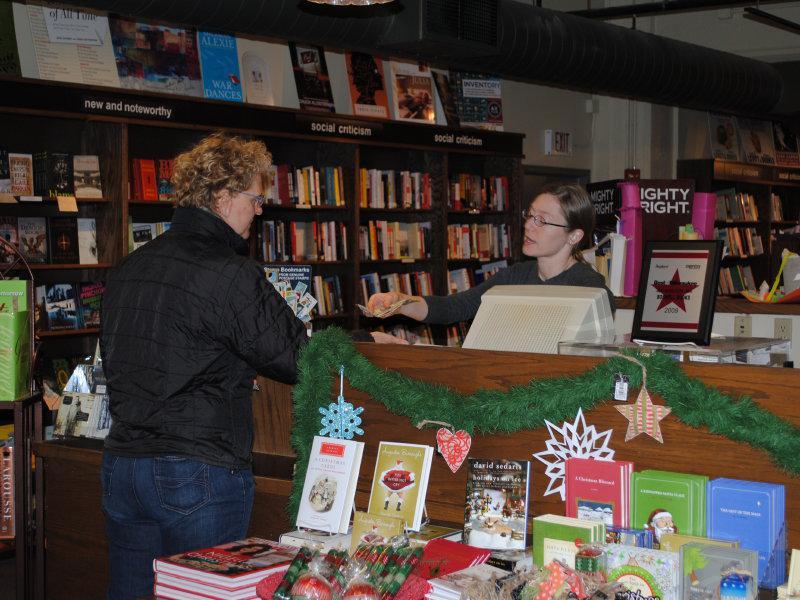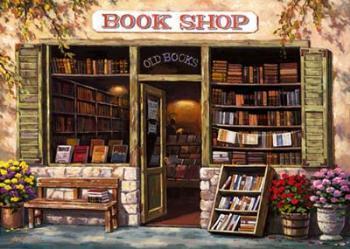The first image is the image on the left, the second image is the image on the right. For the images displayed, is the sentence "In one image there is a man with a beard in a bookstore." factually correct? Answer yes or no. No. The first image is the image on the left, the second image is the image on the right. Assess this claim about the two images: "A man with a gray beard and glasses stands behind a counter stacked with books in one image, and the other image shows a display with a book's front cover.". Correct or not? Answer yes or no. No. 